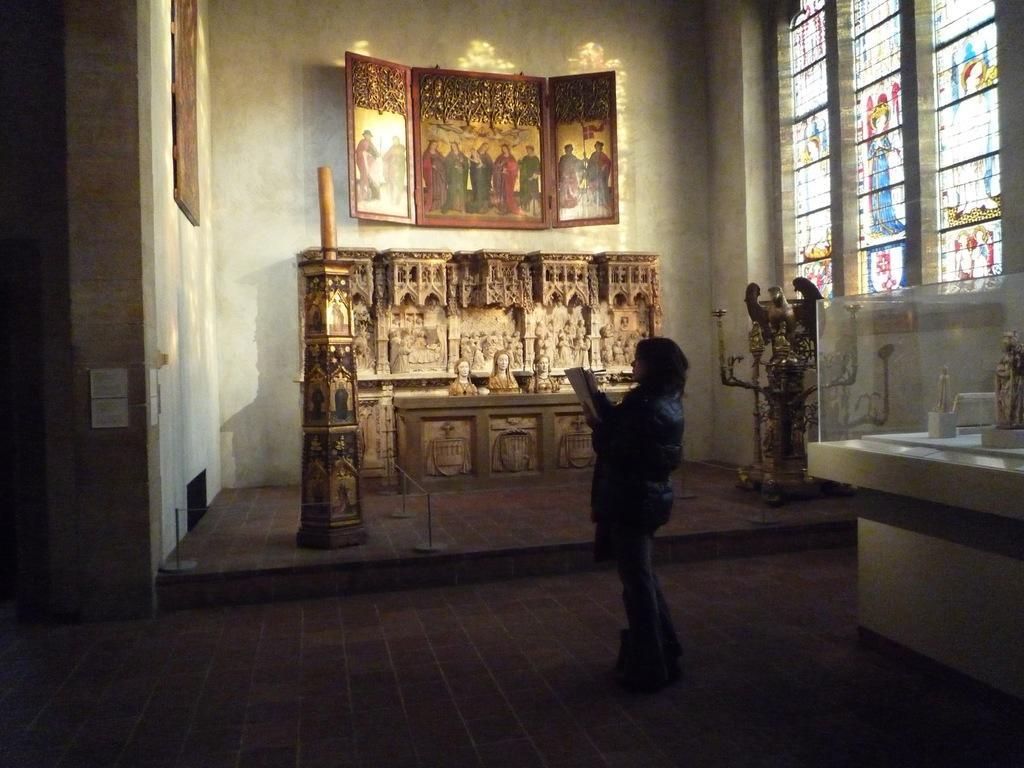Can you describe this image briefly? In the image there is a woman standing in the middle in boots holding a book inside a building, in the front there are paintings and sculptures and a window on the right side wall and painting on the left side wall, on the right side there is a table with idols on it inside a glass. 